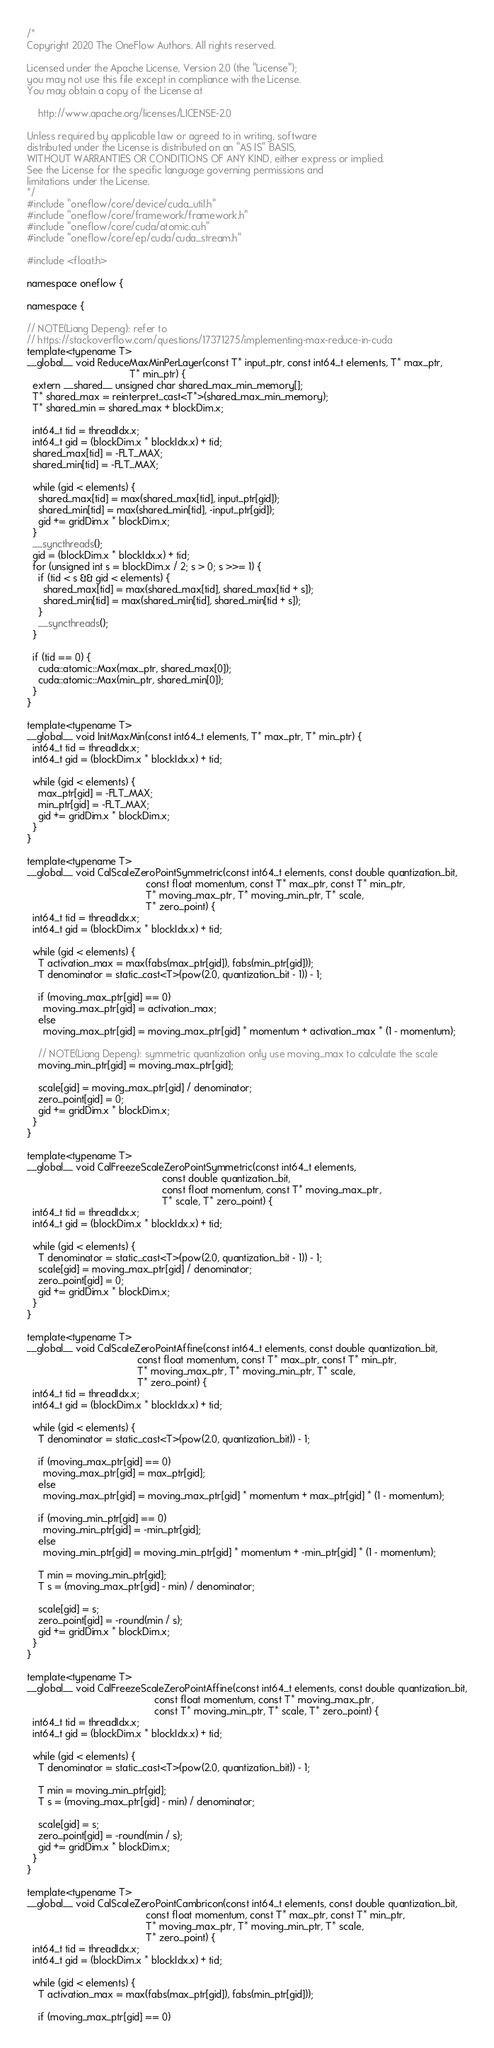Convert code to text. <code><loc_0><loc_0><loc_500><loc_500><_Cuda_>/*
Copyright 2020 The OneFlow Authors. All rights reserved.

Licensed under the Apache License, Version 2.0 (the "License");
you may not use this file except in compliance with the License.
You may obtain a copy of the License at

    http://www.apache.org/licenses/LICENSE-2.0

Unless required by applicable law or agreed to in writing, software
distributed under the License is distributed on an "AS IS" BASIS,
WITHOUT WARRANTIES OR CONDITIONS OF ANY KIND, either express or implied.
See the License for the specific language governing permissions and
limitations under the License.
*/
#include "oneflow/core/device/cuda_util.h"
#include "oneflow/core/framework/framework.h"
#include "oneflow/core/cuda/atomic.cuh"
#include "oneflow/core/ep/cuda/cuda_stream.h"

#include <float.h>

namespace oneflow {

namespace {

// NOTE(Liang Depeng): refer to
// https://stackoverflow.com/questions/17371275/implementing-max-reduce-in-cuda
template<typename T>
__global__ void ReduceMaxMinPerLayer(const T* input_ptr, const int64_t elements, T* max_ptr,
                                     T* min_ptr) {
  extern __shared__ unsigned char shared_max_min_memory[];
  T* shared_max = reinterpret_cast<T*>(shared_max_min_memory);
  T* shared_min = shared_max + blockDim.x;

  int64_t tid = threadIdx.x;
  int64_t gid = (blockDim.x * blockIdx.x) + tid;
  shared_max[tid] = -FLT_MAX;
  shared_min[tid] = -FLT_MAX;

  while (gid < elements) {
    shared_max[tid] = max(shared_max[tid], input_ptr[gid]);
    shared_min[tid] = max(shared_min[tid], -input_ptr[gid]);
    gid += gridDim.x * blockDim.x;
  }
  __syncthreads();
  gid = (blockDim.x * blockIdx.x) + tid;
  for (unsigned int s = blockDim.x / 2; s > 0; s >>= 1) {
    if (tid < s && gid < elements) {
      shared_max[tid] = max(shared_max[tid], shared_max[tid + s]);
      shared_min[tid] = max(shared_min[tid], shared_min[tid + s]);
    }
    __syncthreads();
  }

  if (tid == 0) {
    cuda::atomic::Max(max_ptr, shared_max[0]);
    cuda::atomic::Max(min_ptr, shared_min[0]);
  }
}

template<typename T>
__global__ void InitMaxMin(const int64_t elements, T* max_ptr, T* min_ptr) {
  int64_t tid = threadIdx.x;
  int64_t gid = (blockDim.x * blockIdx.x) + tid;

  while (gid < elements) {
    max_ptr[gid] = -FLT_MAX;
    min_ptr[gid] = -FLT_MAX;
    gid += gridDim.x * blockDim.x;
  }
}

template<typename T>
__global__ void CalScaleZeroPointSymmetric(const int64_t elements, const double quantization_bit,
                                           const float momentum, const T* max_ptr, const T* min_ptr,
                                           T* moving_max_ptr, T* moving_min_ptr, T* scale,
                                           T* zero_point) {
  int64_t tid = threadIdx.x;
  int64_t gid = (blockDim.x * blockIdx.x) + tid;

  while (gid < elements) {
    T activation_max = max(fabs(max_ptr[gid]), fabs(min_ptr[gid]));
    T denominator = static_cast<T>(pow(2.0, quantization_bit - 1)) - 1;

    if (moving_max_ptr[gid] == 0)
      moving_max_ptr[gid] = activation_max;
    else
      moving_max_ptr[gid] = moving_max_ptr[gid] * momentum + activation_max * (1 - momentum);

    // NOTE(Liang Depeng): symmetric quantization only use moving_max to calculate the scale
    moving_min_ptr[gid] = moving_max_ptr[gid];

    scale[gid] = moving_max_ptr[gid] / denominator;
    zero_point[gid] = 0;
    gid += gridDim.x * blockDim.x;
  }
}

template<typename T>
__global__ void CalFreezeScaleZeroPointSymmetric(const int64_t elements,
                                                 const double quantization_bit,
                                                 const float momentum, const T* moving_max_ptr,
                                                 T* scale, T* zero_point) {
  int64_t tid = threadIdx.x;
  int64_t gid = (blockDim.x * blockIdx.x) + tid;

  while (gid < elements) {
    T denominator = static_cast<T>(pow(2.0, quantization_bit - 1)) - 1;
    scale[gid] = moving_max_ptr[gid] / denominator;
    zero_point[gid] = 0;
    gid += gridDim.x * blockDim.x;
  }
}

template<typename T>
__global__ void CalScaleZeroPointAffine(const int64_t elements, const double quantization_bit,
                                        const float momentum, const T* max_ptr, const T* min_ptr,
                                        T* moving_max_ptr, T* moving_min_ptr, T* scale,
                                        T* zero_point) {
  int64_t tid = threadIdx.x;
  int64_t gid = (blockDim.x * blockIdx.x) + tid;

  while (gid < elements) {
    T denominator = static_cast<T>(pow(2.0, quantization_bit)) - 1;

    if (moving_max_ptr[gid] == 0)
      moving_max_ptr[gid] = max_ptr[gid];
    else
      moving_max_ptr[gid] = moving_max_ptr[gid] * momentum + max_ptr[gid] * (1 - momentum);

    if (moving_min_ptr[gid] == 0)
      moving_min_ptr[gid] = -min_ptr[gid];
    else
      moving_min_ptr[gid] = moving_min_ptr[gid] * momentum + -min_ptr[gid] * (1 - momentum);

    T min = moving_min_ptr[gid];
    T s = (moving_max_ptr[gid] - min) / denominator;

    scale[gid] = s;
    zero_point[gid] = -round(min / s);
    gid += gridDim.x * blockDim.x;
  }
}

template<typename T>
__global__ void CalFreezeScaleZeroPointAffine(const int64_t elements, const double quantization_bit,
                                              const float momentum, const T* moving_max_ptr,
                                              const T* moving_min_ptr, T* scale, T* zero_point) {
  int64_t tid = threadIdx.x;
  int64_t gid = (blockDim.x * blockIdx.x) + tid;

  while (gid < elements) {
    T denominator = static_cast<T>(pow(2.0, quantization_bit)) - 1;

    T min = moving_min_ptr[gid];
    T s = (moving_max_ptr[gid] - min) / denominator;

    scale[gid] = s;
    zero_point[gid] = -round(min / s);
    gid += gridDim.x * blockDim.x;
  }
}

template<typename T>
__global__ void CalScaleZeroPointCambricon(const int64_t elements, const double quantization_bit,
                                           const float momentum, const T* max_ptr, const T* min_ptr,
                                           T* moving_max_ptr, T* moving_min_ptr, T* scale,
                                           T* zero_point) {
  int64_t tid = threadIdx.x;
  int64_t gid = (blockDim.x * blockIdx.x) + tid;

  while (gid < elements) {
    T activation_max = max(fabs(max_ptr[gid]), fabs(min_ptr[gid]));

    if (moving_max_ptr[gid] == 0)</code> 